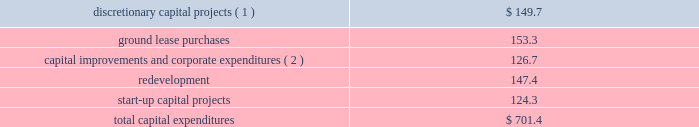As of december 31 , 2016 , we had total outstanding indebtedness of $ 18.7 billion , with a current portion of $ 238.8 million .
During the year ended december 31 , 2016 , we generated sufficient cash flow from operations to fund our capital expenditures and debt service obligations , as well as our required distributions .
We believe the cash generated by operating activities during the year ending december 31 , 2017 will be sufficient to fund our required distributions , capital expenditures , debt service obligations ( interest and principal repayments ) and signed acquisitions .
As of december 31 , 2016 , we had $ 423.0 million of cash and cash equivalents held by our foreign subsidiaries , of which $ 183.9 million was held by our joint ventures .
While certain subsidiaries may pay us interest or principal on intercompany debt , it has not been our practice to repatriate earnings from our foreign subsidiaries primarily due to our ongoing expansion efforts and related capital needs .
However , in the event that we do repatriate any funds , we may be required to accrue and pay taxes .
Cash flows from operating activities for the year ended december 31 , 2016 , cash provided by operating activities increased $ 520.6 million as compared to the year ended december 31 , 2015 .
The primary factors that impacted cash provided by operating activities as compared to the year ended december 31 , 2015 , include : 2022 an increase in our operating profit of $ 490.8 million ; 2022 an increase of approximately $ 67.1 million in cash paid for interest ; and 2022 a decrease of approximately $ 60.8 million in cash paid for taxes .
For the year ended december 31 , 2015 , cash provided by operating activities increased $ 48.5 million as compared to the year ended december 31 , 2014 .
The primary factors that impacted cash provided by operating activities as compared to the year ended december 31 , 2014 , include : 2022 an increase in our operating profit of $ 433.3 million ; 2022 an increase of approximately $ 87.8 million in cash paid for taxes , driven primarily by the mipt one-time cash tax charge of $ 93.0 million ; 2022 a decrease in capital contributions , tenant settlements and other prepayments of approximately $ 99.0 million ; 2022 an increase of approximately $ 29.9 million in cash paid for interest ; 2022 a decrease of approximately $ 34.9 million in termination and decommissioning fees ; 2022 a decrease of approximately $ 49.0 million in tenant receipts due to timing ; and 2022 a decrease due to the non-recurrence of a 2014 value added tax refund of approximately $ 60.3 million .
Cash flows from investing activities our significant investing activities during the year ended december 31 , 2016 are highlighted below : 2022 we spent approximately $ 1.1 billion for the viom acquisition .
2022 we spent $ 701.4 million for capital expenditures , as follows ( in millions ) : .
_______________ ( 1 ) includes the construction of 1869 communications sites globally .
( 2 ) includes $ 18.9 million of capital lease payments included in repayments of notes payable , credit facilities , term loan , senior notes and capital leases in the cash flow from financing activities in our consolidated statement of cash flows .
Our significant investing transactions in 2015 included the following : 2022 we spent $ 5.059 billion for the verizon transaction .
2022 we spent $ 796.9 million for the acquisition of 5483 communications sites from tim in brazil .
2022 we spent $ 1.1 billion for the acquisition of 4716 communications sites from certain of airtel 2019s subsidiaries in nigeria. .
What portion of the total capital expenditures is related to start-up capital projects? 
Computations: (124.3 / 701.4)
Answer: 0.17722. 